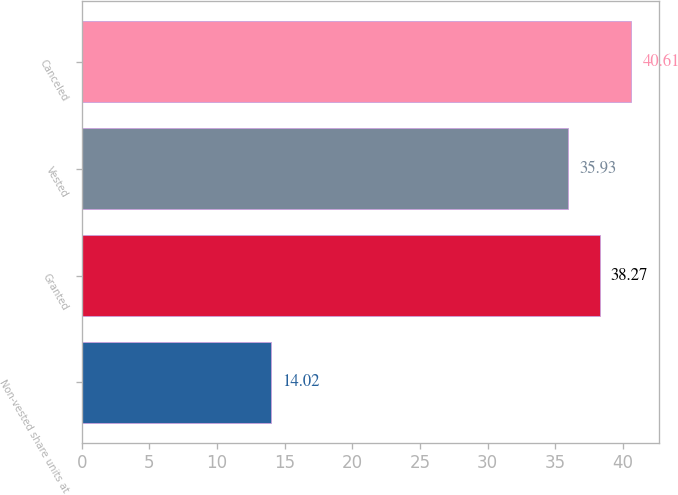Convert chart to OTSL. <chart><loc_0><loc_0><loc_500><loc_500><bar_chart><fcel>Non-vested share units at<fcel>Granted<fcel>Vested<fcel>Canceled<nl><fcel>14.02<fcel>38.27<fcel>35.93<fcel>40.61<nl></chart> 